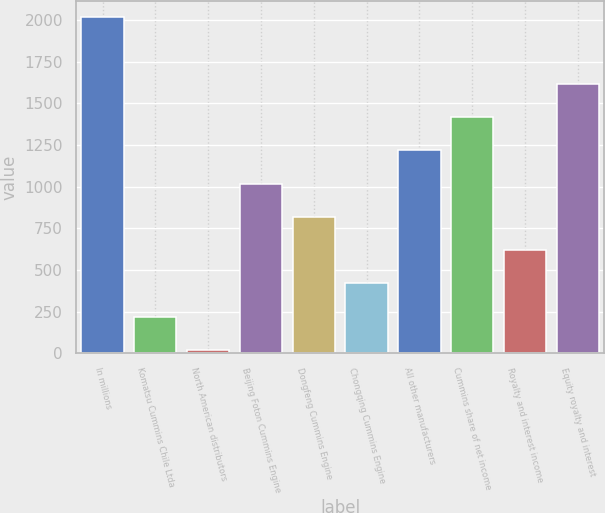Convert chart. <chart><loc_0><loc_0><loc_500><loc_500><bar_chart><fcel>In millions<fcel>Komatsu Cummins Chile Ltda<fcel>North American distributors<fcel>Beijing Foton Cummins Engine<fcel>Dongfeng Cummins Engine<fcel>Chongqing Cummins Engine<fcel>All other manufacturers<fcel>Cummins share of net income<fcel>Royalty and interest income<fcel>Equity royalty and interest<nl><fcel>2016<fcel>220.5<fcel>21<fcel>1018.5<fcel>819<fcel>420<fcel>1218<fcel>1417.5<fcel>619.5<fcel>1617<nl></chart> 